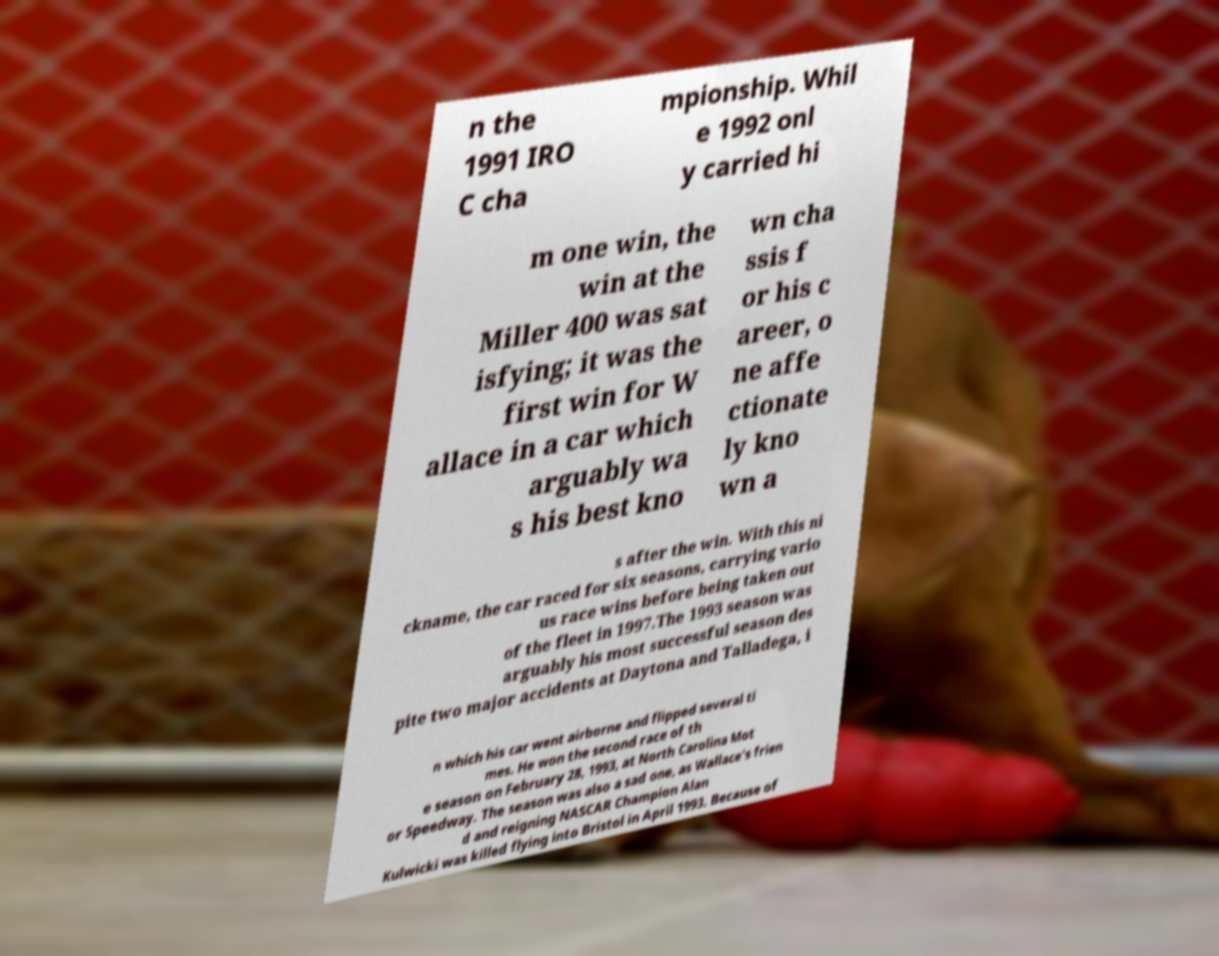Can you read and provide the text displayed in the image?This photo seems to have some interesting text. Can you extract and type it out for me? n the 1991 IRO C cha mpionship. Whil e 1992 onl y carried hi m one win, the win at the Miller 400 was sat isfying; it was the first win for W allace in a car which arguably wa s his best kno wn cha ssis f or his c areer, o ne affe ctionate ly kno wn a s after the win. With this ni ckname, the car raced for six seasons, carrying vario us race wins before being taken out of the fleet in 1997.The 1993 season was arguably his most successful season des pite two major accidents at Daytona and Talladega, i n which his car went airborne and flipped several ti mes. He won the second race of th e season on February 28, 1993, at North Carolina Mot or Speedway. The season was also a sad one, as Wallace's frien d and reigning NASCAR Champion Alan Kulwicki was killed flying into Bristol in April 1993. Because of 